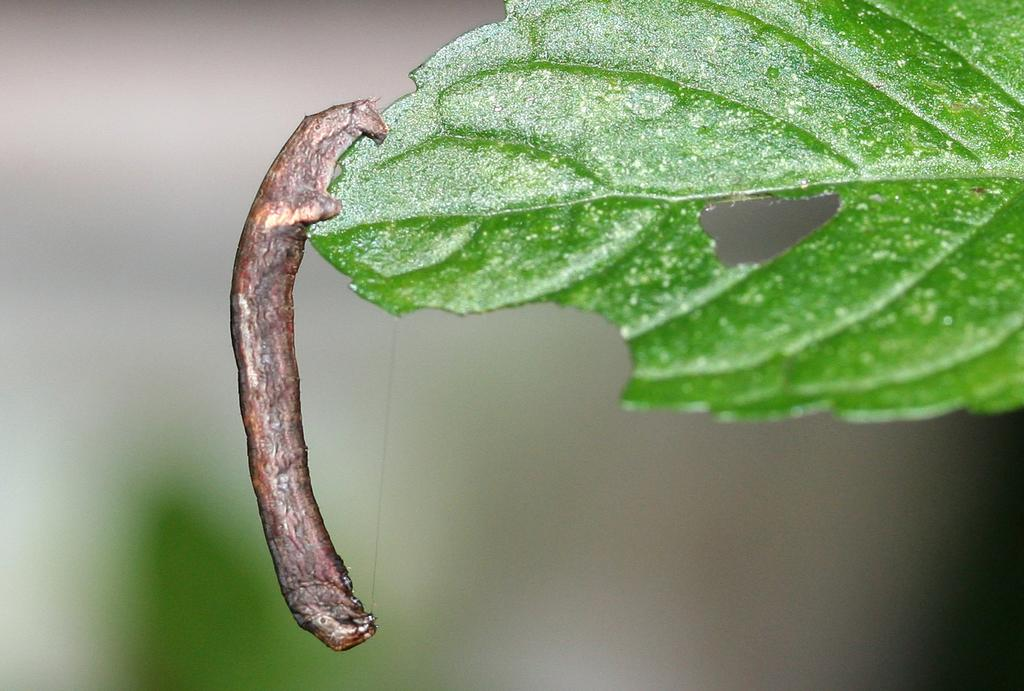What is present in the image that is small and has multiple legs? There is an insect in the image. Where is the insect located in the image? The insect is sitting on a leaf. What can be observed about the background of the image? The background of the image is blurred. What type of industry can be seen in the background of the image? There is no industry present in the image; the background is blurred and does not show any specific setting or environment. 